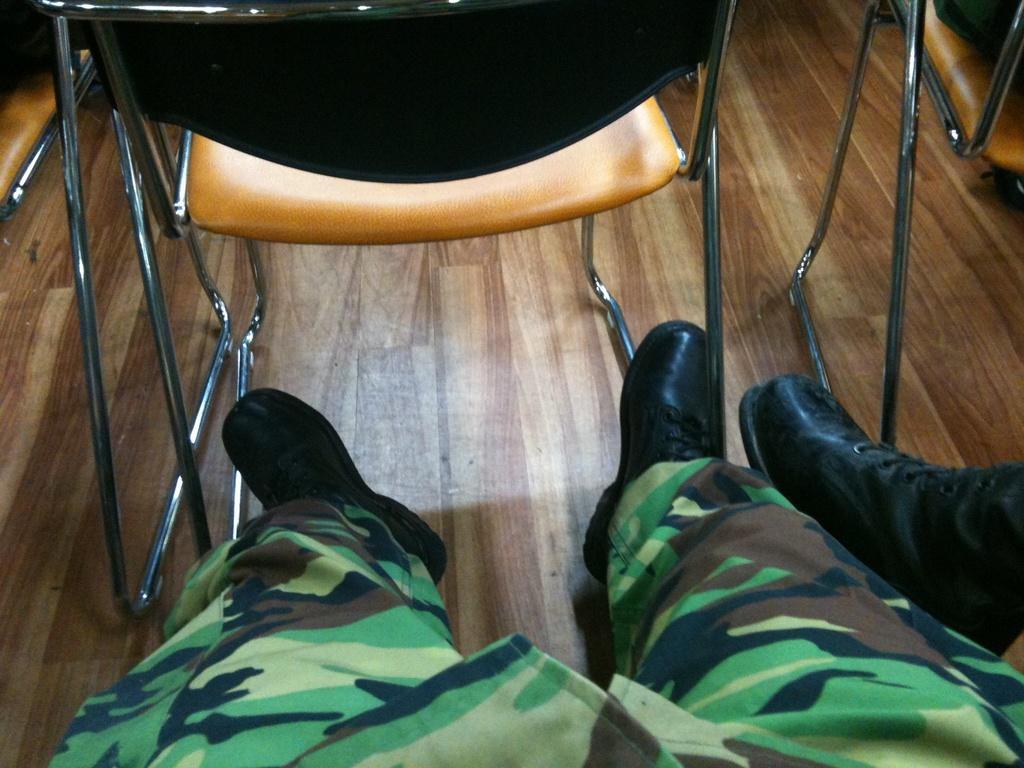Describe this image in one or two sentences. In the picture we can see a chair on the wooden floor and behind it, we can see a person's leg with army trouser and black shoes and beside it also we can see a shoe which is black in color and in front of it we can see a part of the chair. 